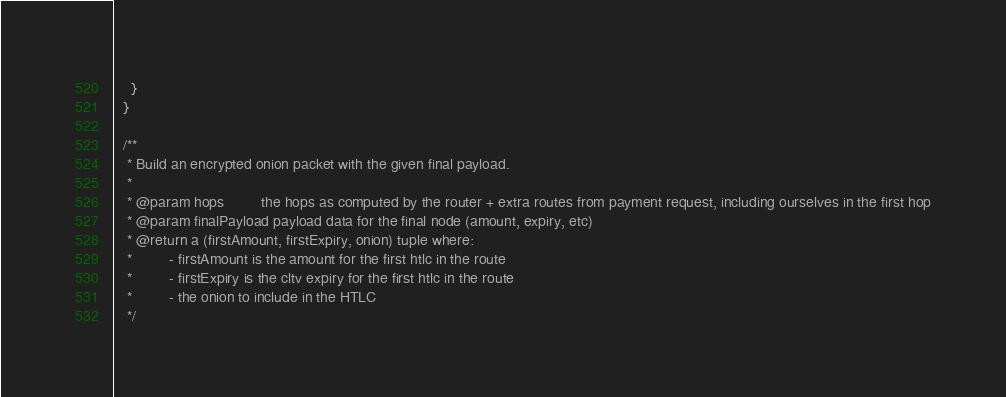Convert code to text. <code><loc_0><loc_0><loc_500><loc_500><_Scala_>    }
  }

  /**
   * Build an encrypted onion packet with the given final payload.
   *
   * @param hops         the hops as computed by the router + extra routes from payment request, including ourselves in the first hop
   * @param finalPayload payload data for the final node (amount, expiry, etc)
   * @return a (firstAmount, firstExpiry, onion) tuple where:
   *         - firstAmount is the amount for the first htlc in the route
   *         - firstExpiry is the cltv expiry for the first htlc in the route
   *         - the onion to include in the HTLC
   */</code> 